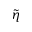Convert formula to latex. <formula><loc_0><loc_0><loc_500><loc_500>\tilde { \eta }</formula> 